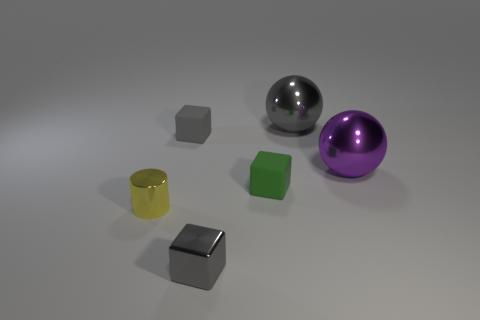Are there fewer metallic cubes that are in front of the small yellow shiny object than purple shiny things that are left of the small green cube?
Give a very brief answer. No. What number of things are small rubber cubes behind the tiny green object or small cylinders?
Offer a very short reply. 2. Do the purple metallic object and the block behind the green block have the same size?
Your response must be concise. No. There is another metal thing that is the same shape as the purple object; what size is it?
Your answer should be compact. Large. There is a rubber thing that is in front of the small gray block behind the big purple shiny thing; how many tiny metallic cylinders are behind it?
Ensure brevity in your answer.  0. What number of cylinders are big gray shiny things or metal things?
Ensure brevity in your answer.  1. What color is the rubber object behind the green matte object that is to the left of the big sphere that is in front of the big gray metal sphere?
Give a very brief answer. Gray. What number of other things are the same size as the metallic cube?
Your answer should be compact. 3. Are there any other things that have the same shape as the gray matte object?
Make the answer very short. Yes. There is another big metal object that is the same shape as the big gray thing; what color is it?
Offer a very short reply. Purple. 